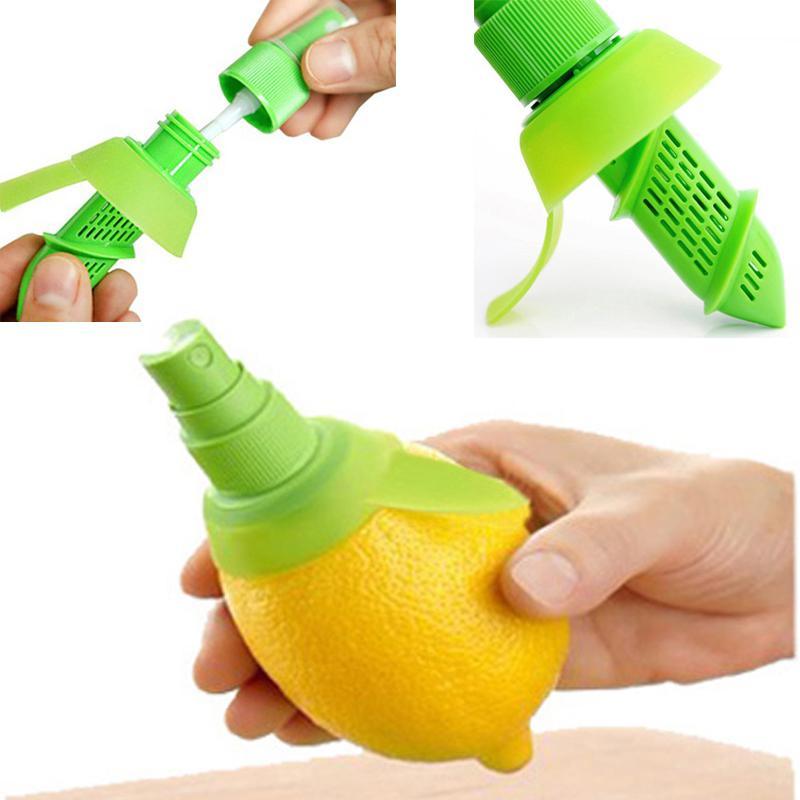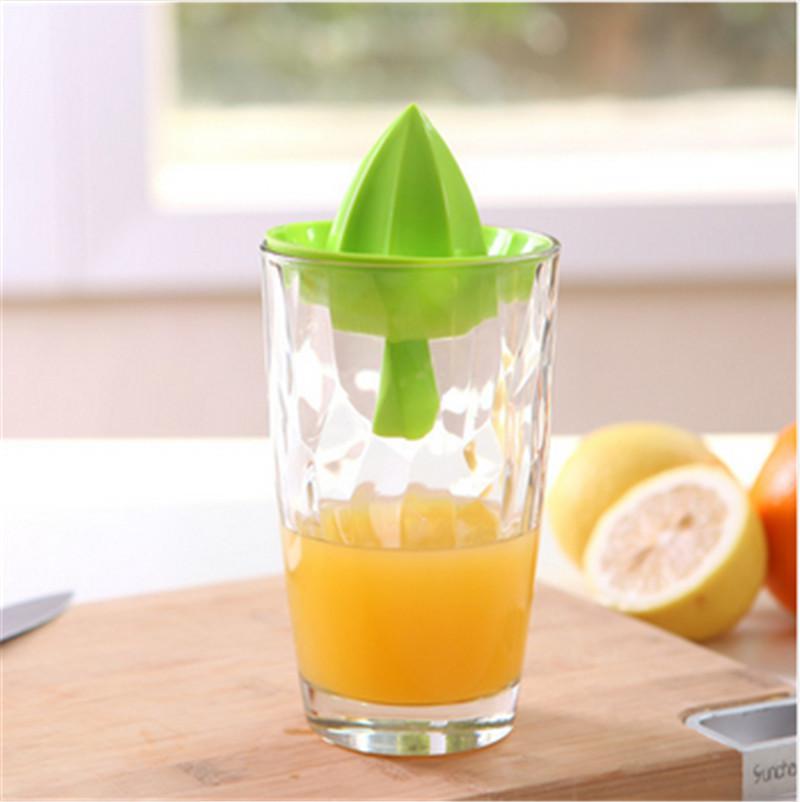The first image is the image on the left, the second image is the image on the right. For the images displayed, is the sentence "A person is holding the lemon in the image on the right." factually correct? Answer yes or no. No. 